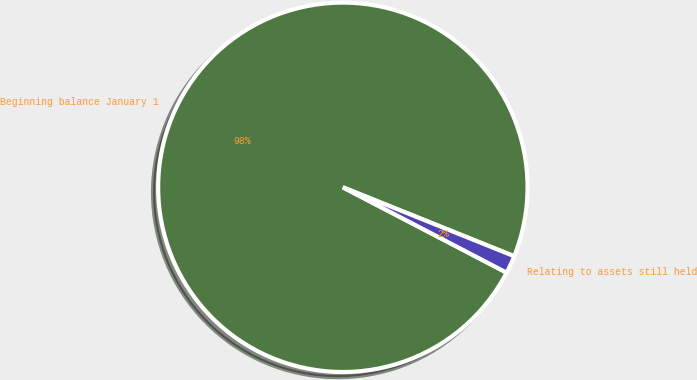<chart> <loc_0><loc_0><loc_500><loc_500><pie_chart><fcel>Beginning balance January 1<fcel>Relating to assets still held<nl><fcel>98.44%<fcel>1.56%<nl></chart> 